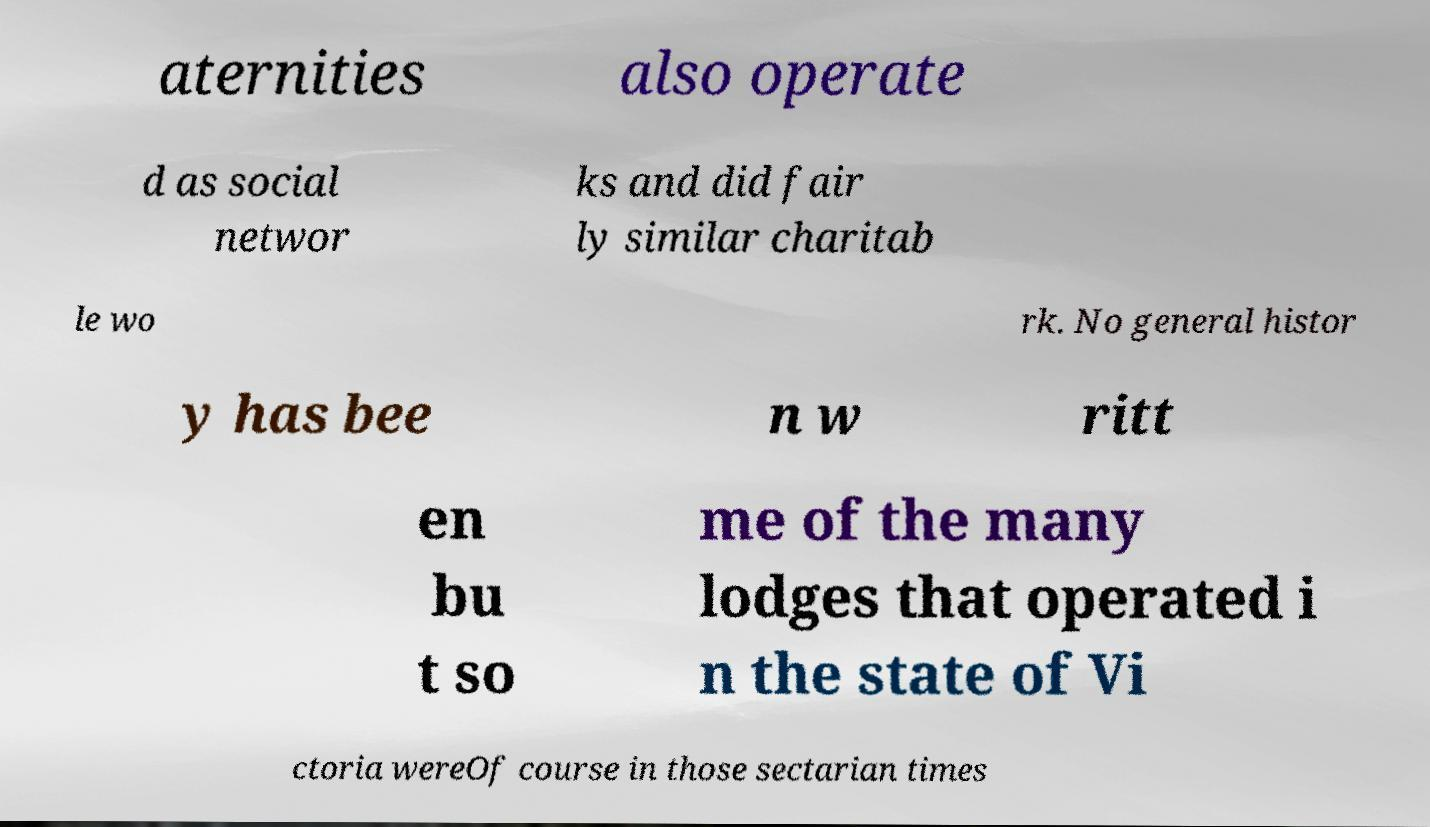Could you assist in decoding the text presented in this image and type it out clearly? aternities also operate d as social networ ks and did fair ly similar charitab le wo rk. No general histor y has bee n w ritt en bu t so me of the many lodges that operated i n the state of Vi ctoria wereOf course in those sectarian times 